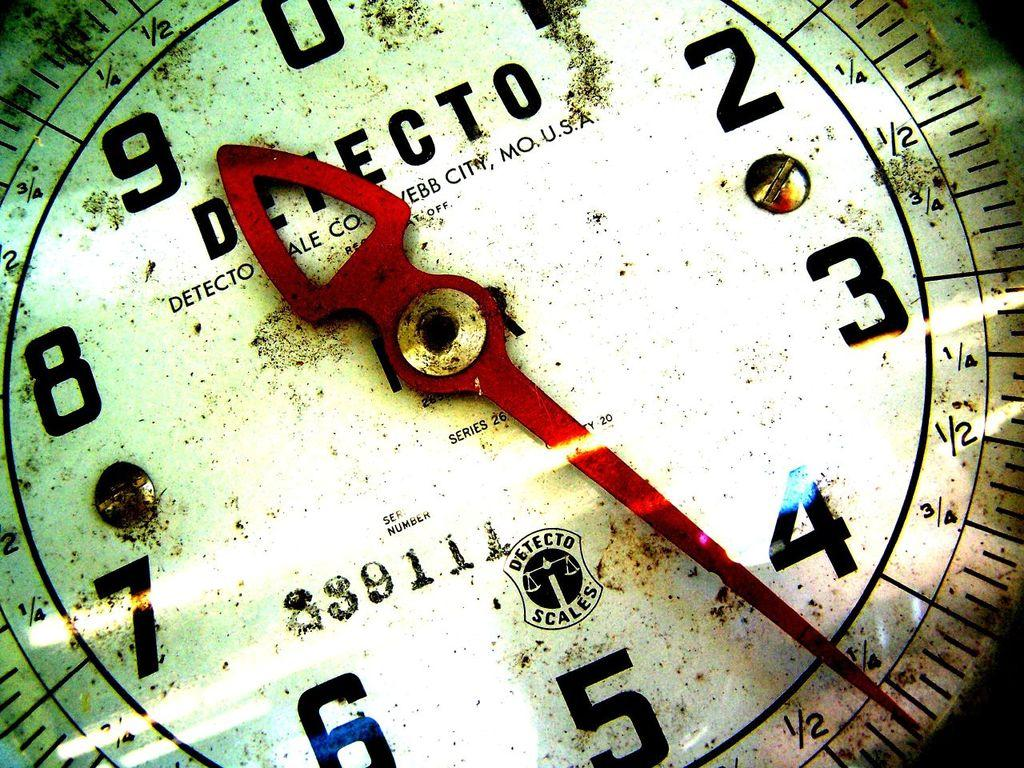Provide a one-sentence caption for the provided image. A white scale with text "DETECTO DETECTO SCALE CO. WEBB CITY, MO. U.S.A" and red pointer. 